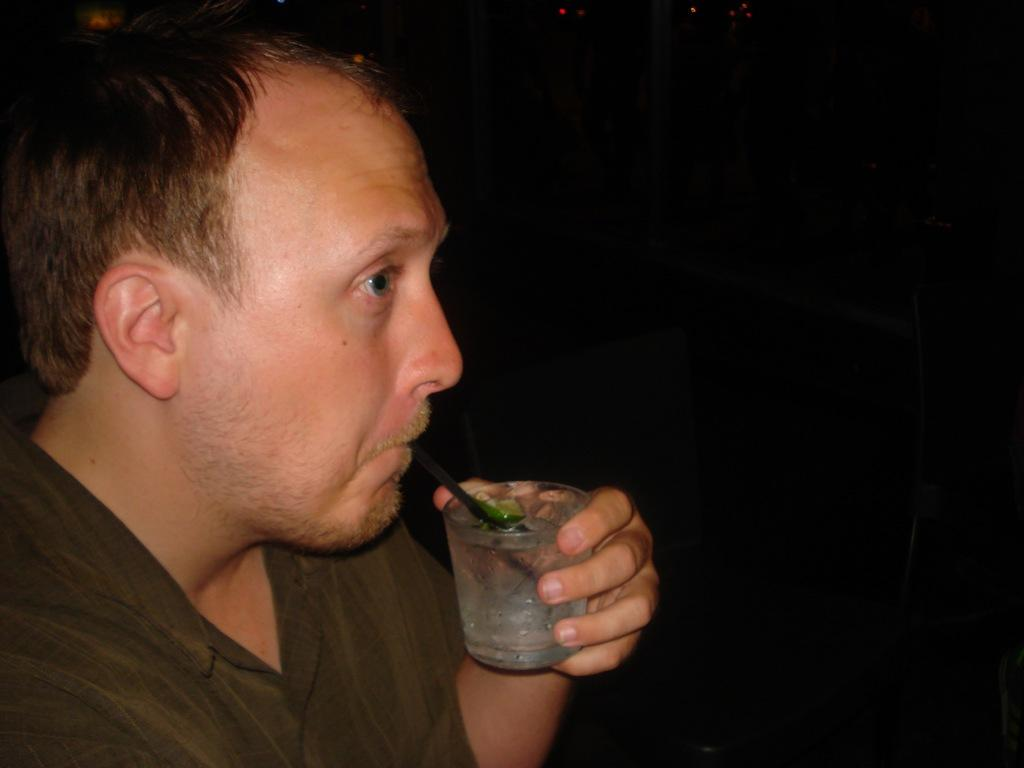Who is present in the image? There is a man in the image. What is the man holding in the image? The man is holding a glass of drink. Can you describe the background of the image? The background of the image is dark. What type of table is visible in the image? There is no table present in the image. What kind of wine is the man drinking in the image? The type of drink the man is holding is not specified, so it cannot be determined if it is wine. 